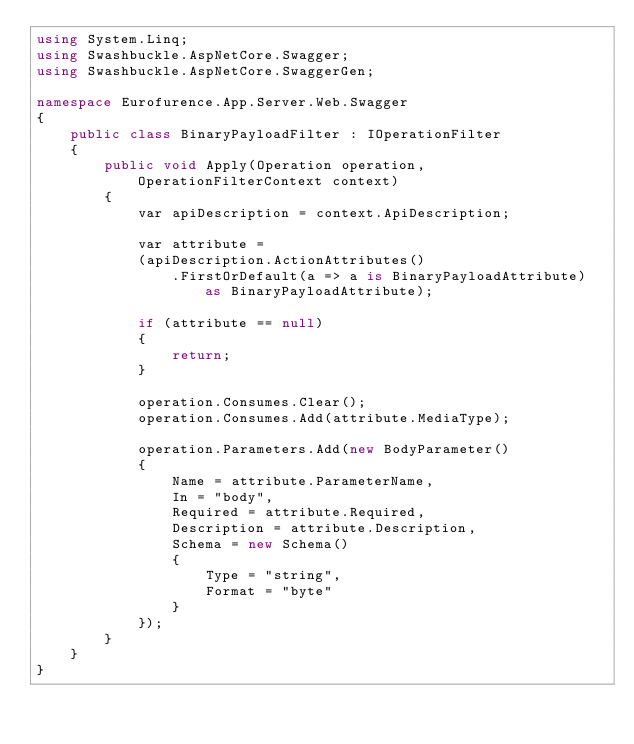Convert code to text. <code><loc_0><loc_0><loc_500><loc_500><_C#_>using System.Linq;
using Swashbuckle.AspNetCore.Swagger;
using Swashbuckle.AspNetCore.SwaggerGen;

namespace Eurofurence.App.Server.Web.Swagger
{
    public class BinaryPayloadFilter : IOperationFilter
    {
        public void Apply(Operation operation, OperationFilterContext context)
        {
            var apiDescription = context.ApiDescription;

            var attribute =
            (apiDescription.ActionAttributes()
                .FirstOrDefault(a => a is BinaryPayloadAttribute) as BinaryPayloadAttribute);

            if (attribute == null)
            {
                return;
            }

            operation.Consumes.Clear();
            operation.Consumes.Add(attribute.MediaType);

            operation.Parameters.Add(new BodyParameter()
            {
                Name = attribute.ParameterName,
                In = "body",
                Required = attribute.Required,
                Description = attribute.Description,
                Schema = new Schema()
                {
                    Type = "string",
                    Format = "byte"
                }
            });
        }
    }
}</code> 